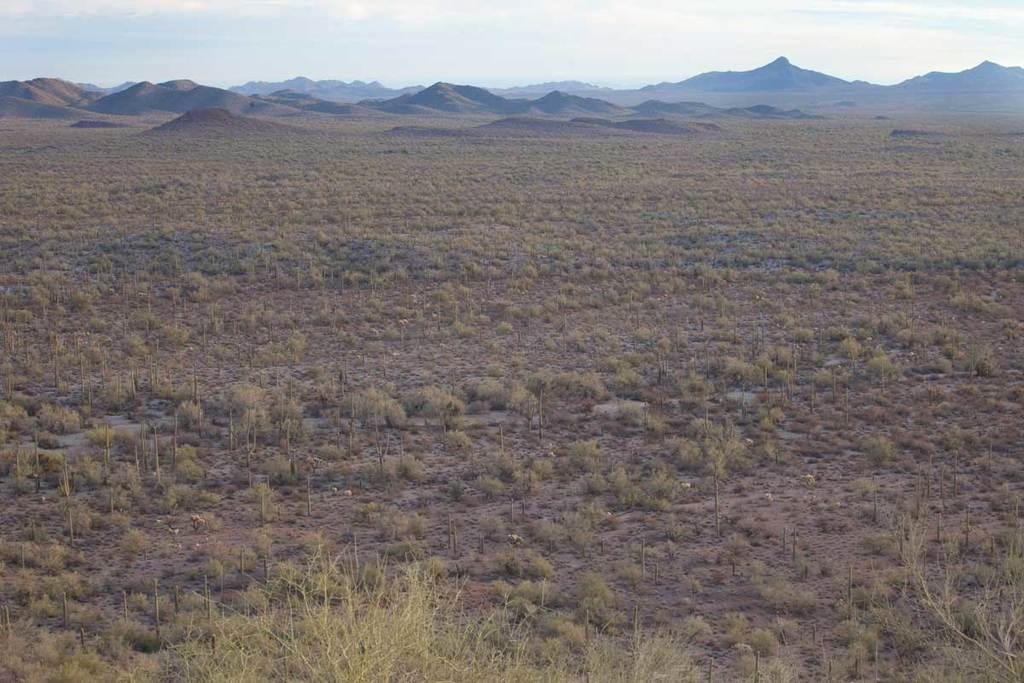What is the main feature of the image? The center of the image contains the sky. What can be seen in the sky? Clouds are present in the sky. What type of landscape is visible in the image? Hills are visible in the image. What type of vegetation is present in the image? Grass is present in the image. How many ants are crawling on the swing in the image? There is no swing or ants present in the image. 